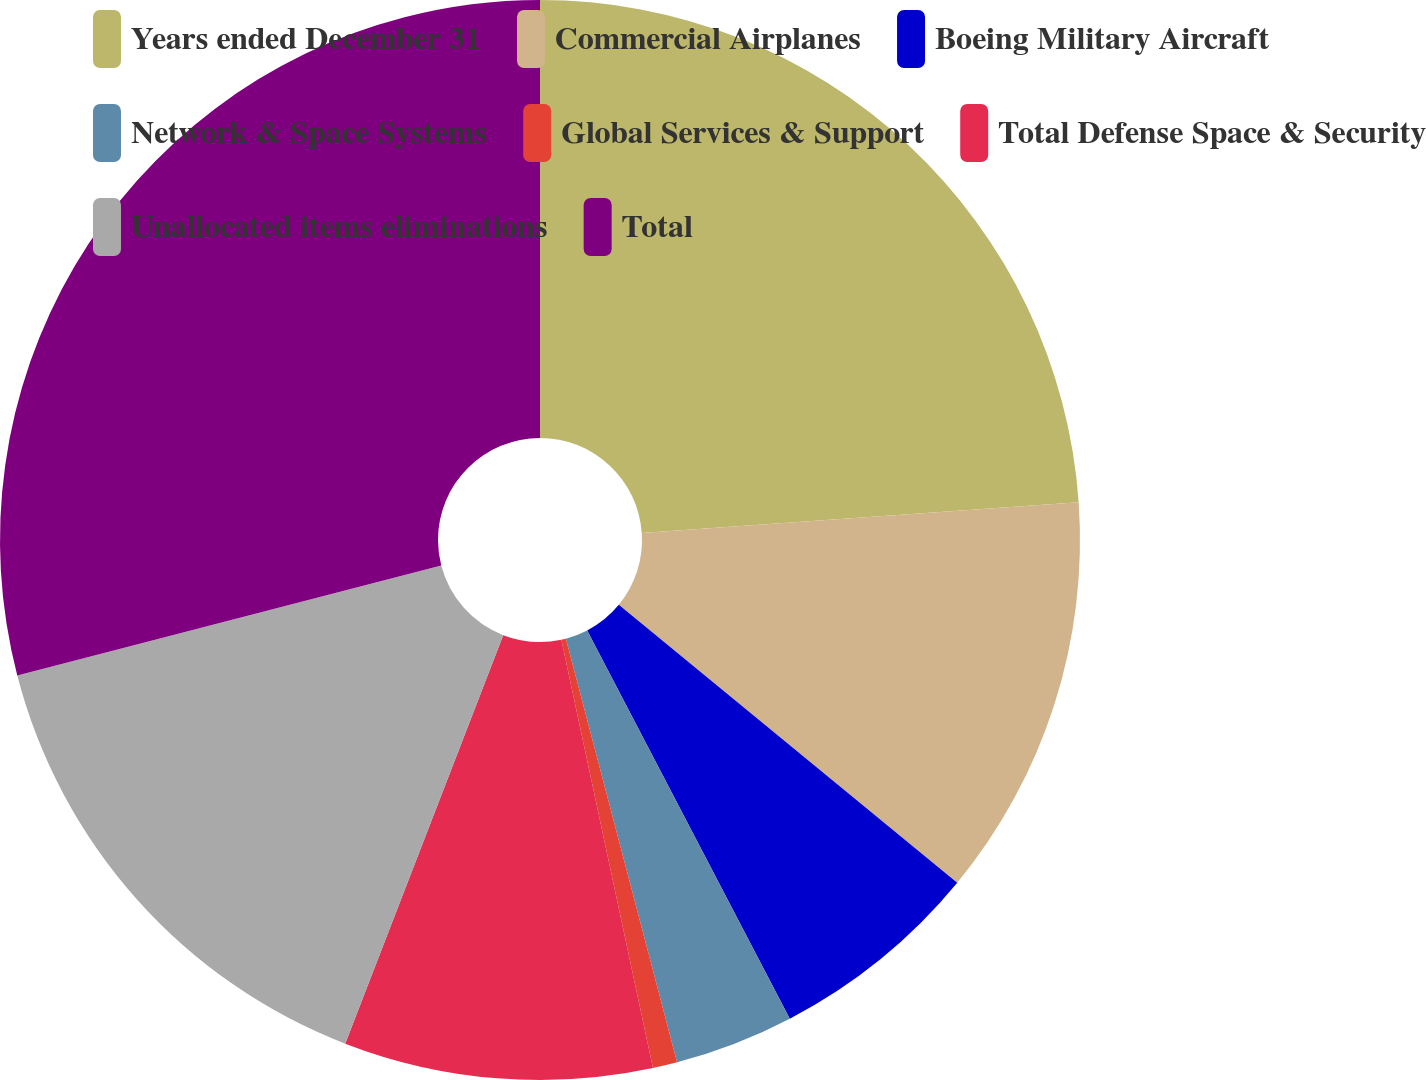Convert chart to OTSL. <chart><loc_0><loc_0><loc_500><loc_500><pie_chart><fcel>Years ended December 31<fcel>Commercial Airplanes<fcel>Boeing Military Aircraft<fcel>Network & Space Systems<fcel>Global Services & Support<fcel>Total Defense Space & Security<fcel>Unallocated items eliminations<fcel>Total<nl><fcel>23.89%<fcel>12.06%<fcel>6.4%<fcel>3.57%<fcel>0.73%<fcel>9.23%<fcel>15.09%<fcel>29.04%<nl></chart> 